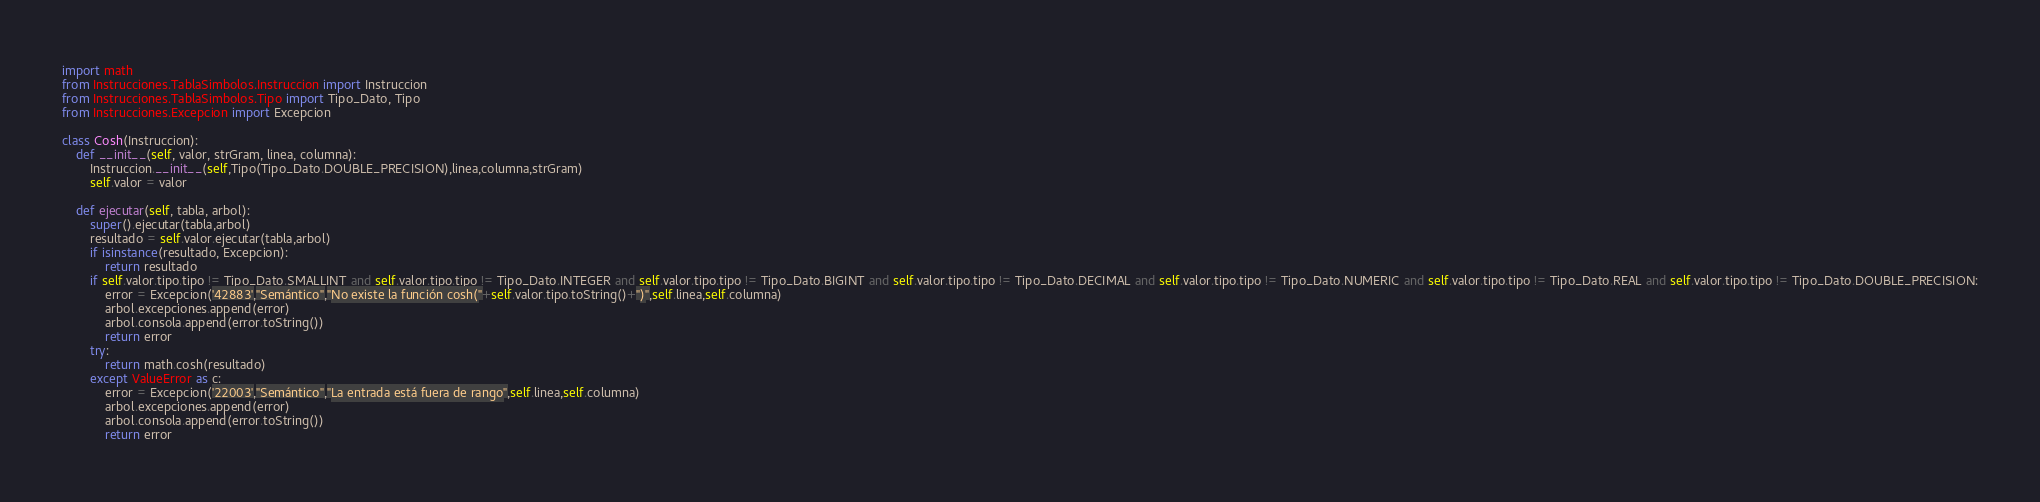Convert code to text. <code><loc_0><loc_0><loc_500><loc_500><_Python_>import math
from Instrucciones.TablaSimbolos.Instruccion import Instruccion
from Instrucciones.TablaSimbolos.Tipo import Tipo_Dato, Tipo
from Instrucciones.Excepcion import Excepcion

class Cosh(Instruccion):
    def __init__(self, valor, strGram, linea, columna):
        Instruccion.__init__(self,Tipo(Tipo_Dato.DOUBLE_PRECISION),linea,columna,strGram)
        self.valor = valor

    def ejecutar(self, tabla, arbol):
        super().ejecutar(tabla,arbol)
        resultado = self.valor.ejecutar(tabla,arbol)
        if isinstance(resultado, Excepcion):
            return resultado
        if self.valor.tipo.tipo != Tipo_Dato.SMALLINT and self.valor.tipo.tipo != Tipo_Dato.INTEGER and self.valor.tipo.tipo != Tipo_Dato.BIGINT and self.valor.tipo.tipo != Tipo_Dato.DECIMAL and self.valor.tipo.tipo != Tipo_Dato.NUMERIC and self.valor.tipo.tipo != Tipo_Dato.REAL and self.valor.tipo.tipo != Tipo_Dato.DOUBLE_PRECISION:
            error = Excepcion('42883',"Semántico","No existe la función cosh("+self.valor.tipo.toString()+")",self.linea,self.columna)
            arbol.excepciones.append(error)
            arbol.consola.append(error.toString())
            return error
        try:
            return math.cosh(resultado)
        except ValueError as c:
            error = Excepcion('22003',"Semántico","La entrada está fuera de rango",self.linea,self.columna)
            arbol.excepciones.append(error)
            arbol.consola.append(error.toString())
            return error</code> 